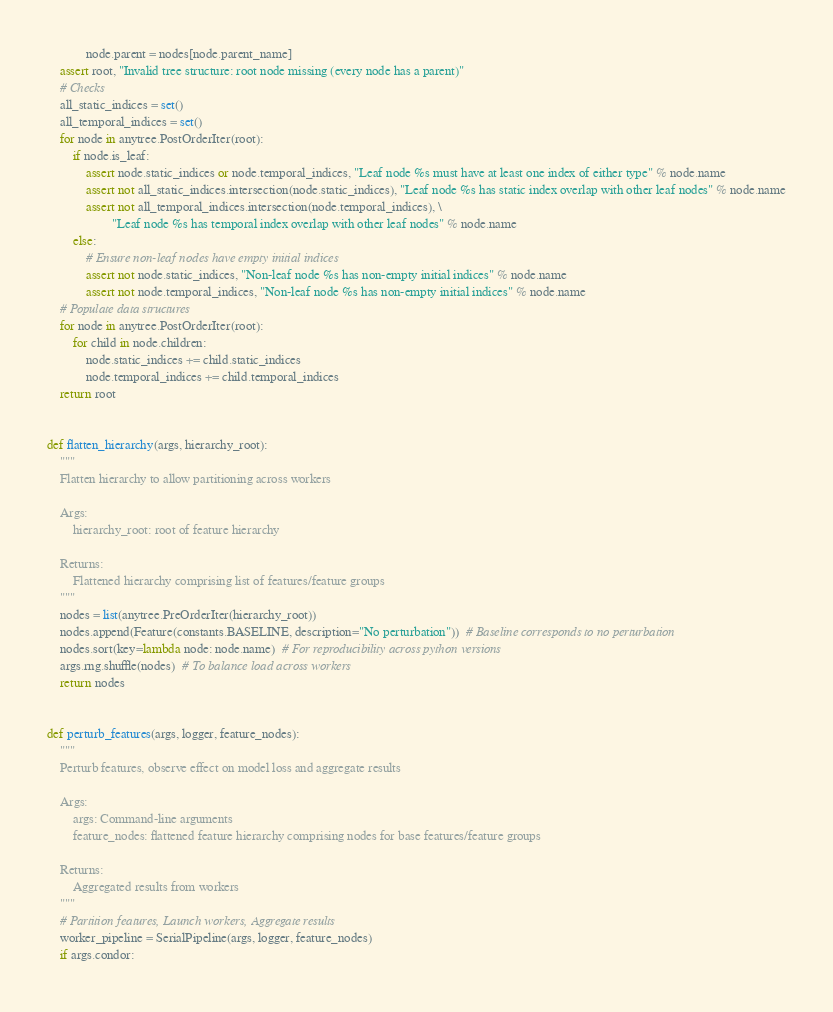Convert code to text. <code><loc_0><loc_0><loc_500><loc_500><_Python_>            node.parent = nodes[node.parent_name]
    assert root, "Invalid tree structure: root node missing (every node has a parent)"
    # Checks
    all_static_indices = set()
    all_temporal_indices = set()
    for node in anytree.PostOrderIter(root):
        if node.is_leaf:
            assert node.static_indices or node.temporal_indices, "Leaf node %s must have at least one index of either type" % node.name
            assert not all_static_indices.intersection(node.static_indices), "Leaf node %s has static index overlap with other leaf nodes" % node.name
            assert not all_temporal_indices.intersection(node.temporal_indices), \
                    "Leaf node %s has temporal index overlap with other leaf nodes" % node.name
        else:
            # Ensure non-leaf nodes have empty initial indices
            assert not node.static_indices, "Non-leaf node %s has non-empty initial indices" % node.name
            assert not node.temporal_indices, "Non-leaf node %s has non-empty initial indices" % node.name
    # Populate data structures
    for node in anytree.PostOrderIter(root):
        for child in node.children:
            node.static_indices += child.static_indices
            node.temporal_indices += child.temporal_indices
    return root


def flatten_hierarchy(args, hierarchy_root):
    """
    Flatten hierarchy to allow partitioning across workers

    Args:
        hierarchy_root: root of feature hierarchy

    Returns:
        Flattened hierarchy comprising list of features/feature groups
    """
    nodes = list(anytree.PreOrderIter(hierarchy_root))
    nodes.append(Feature(constants.BASELINE, description="No perturbation"))  # Baseline corresponds to no perturbation
    nodes.sort(key=lambda node: node.name)  # For reproducibility across python versions
    args.rng.shuffle(nodes)  # To balance load across workers
    return nodes


def perturb_features(args, logger, feature_nodes):
    """
    Perturb features, observe effect on model loss and aggregate results

    Args:
        args: Command-line arguments
        feature_nodes: flattened feature hierarchy comprising nodes for base features/feature groups

    Returns:
        Aggregated results from workers
    """
    # Partition features, Launch workers, Aggregate results
    worker_pipeline = SerialPipeline(args, logger, feature_nodes)
    if args.condor:</code> 